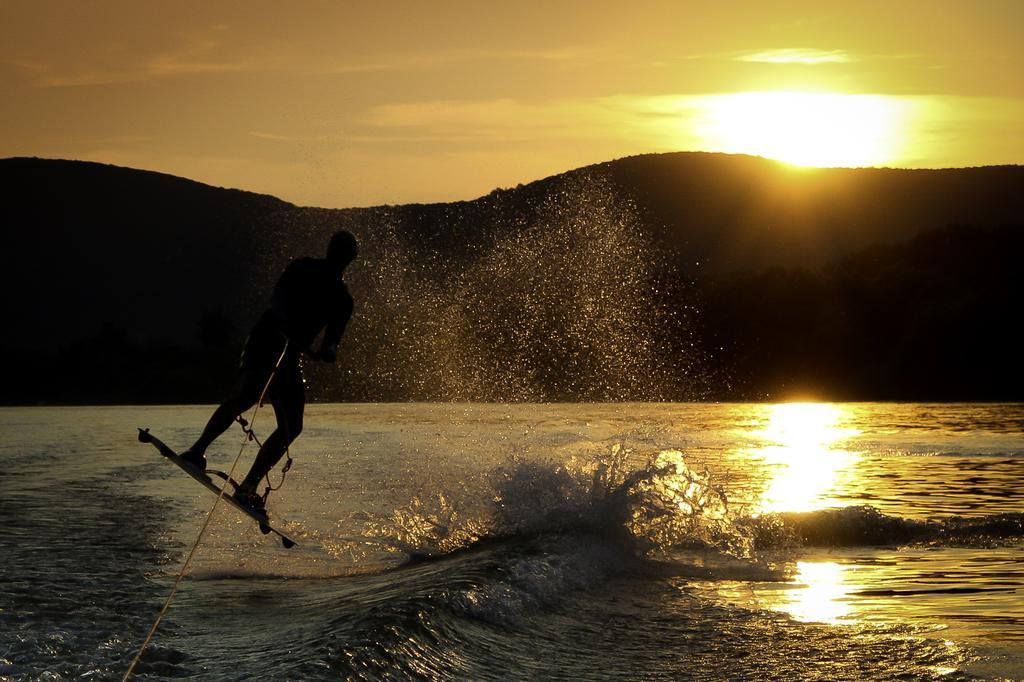Describe this image in one or two sentences. In the foreground of this image, there is a man on a surfing board and holding a rope and he is in the air. On the bottom, there is water. In the background, there are mountains, sunset, sky and the cloud. 